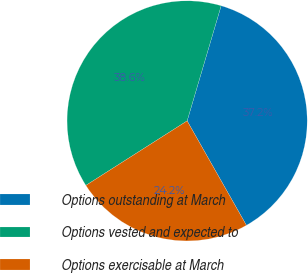<chart> <loc_0><loc_0><loc_500><loc_500><pie_chart><fcel>Options outstanding at March<fcel>Options vested and expected to<fcel>Options exercisable at March<nl><fcel>37.21%<fcel>38.6%<fcel>24.19%<nl></chart> 